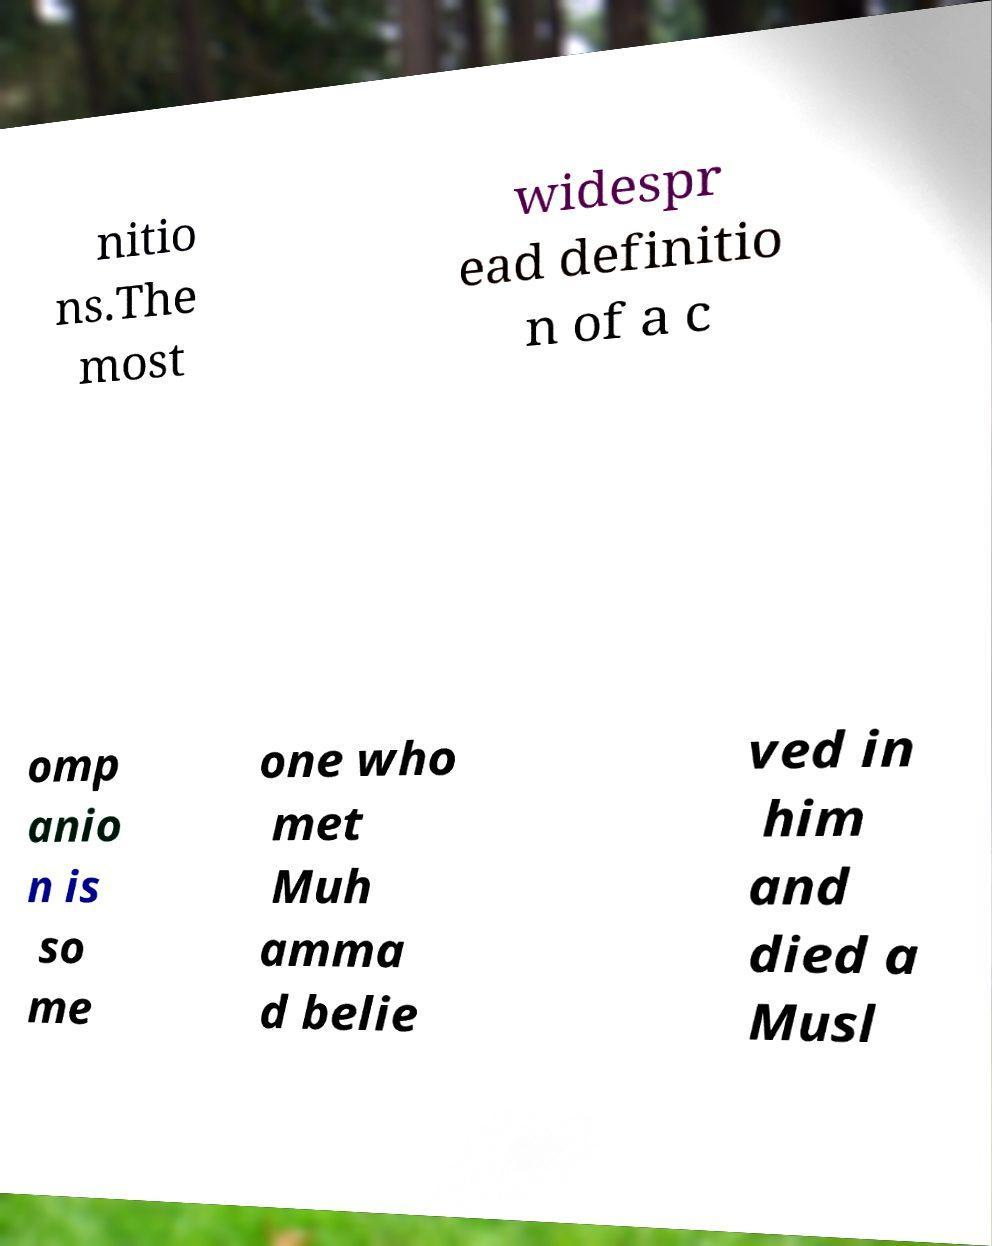Can you read and provide the text displayed in the image?This photo seems to have some interesting text. Can you extract and type it out for me? nitio ns.The most widespr ead definitio n of a c omp anio n is so me one who met Muh amma d belie ved in him and died a Musl 